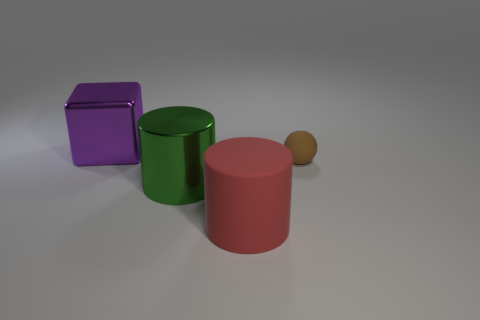Are there any other things that have the same size as the brown ball?
Provide a short and direct response. No. There is a metallic object that is in front of the purple metal block; what shape is it?
Keep it short and to the point. Cylinder. Are there the same number of brown matte objects that are right of the rubber sphere and big metal things behind the large green metal cylinder?
Ensure brevity in your answer.  No. What number of other things are the same size as the brown ball?
Keep it short and to the point. 0. What size is the brown sphere?
Your answer should be very brief. Small. Do the tiny object and the cylinder on the right side of the large green thing have the same material?
Your response must be concise. Yes. Is there another large metal object of the same shape as the red thing?
Ensure brevity in your answer.  Yes. There is another cylinder that is the same size as the green cylinder; what is its material?
Give a very brief answer. Rubber. What size is the matte cylinder that is to the left of the tiny matte object?
Your answer should be compact. Large. Does the thing left of the green metal thing have the same size as the rubber thing in front of the small brown thing?
Keep it short and to the point. Yes. 